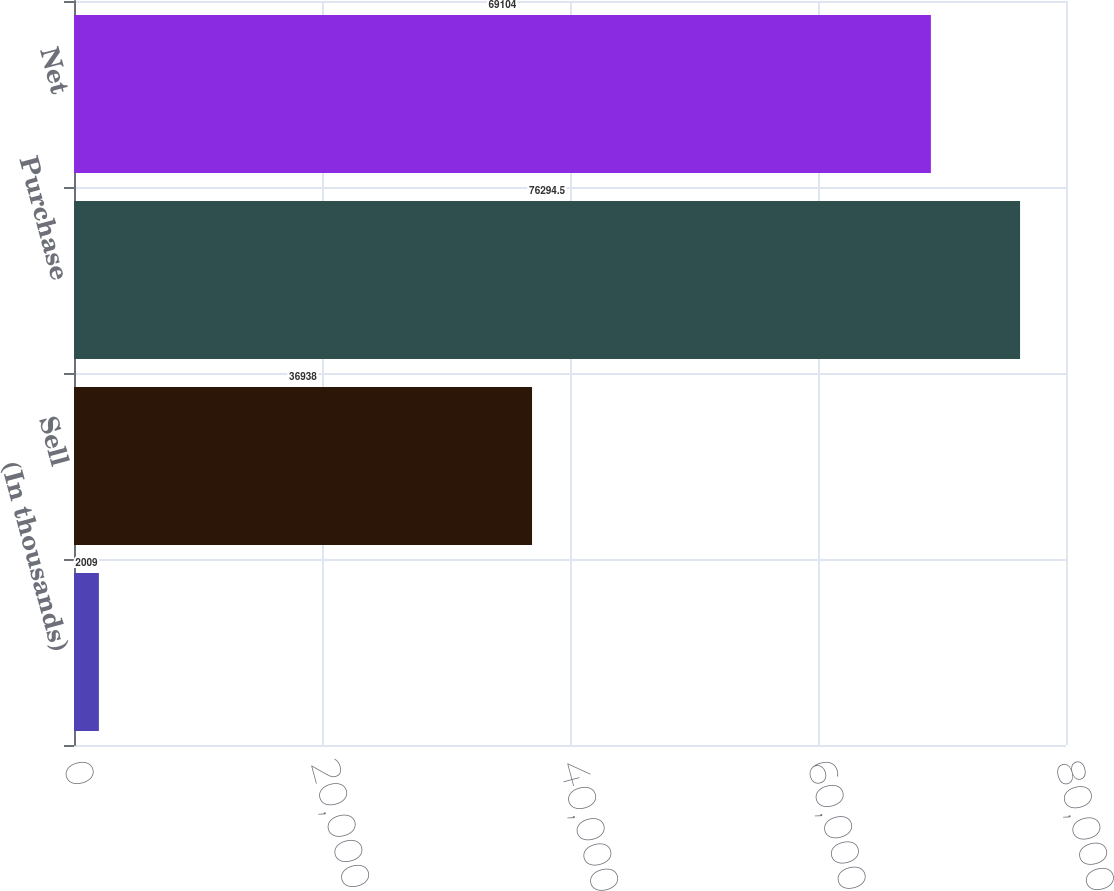Convert chart. <chart><loc_0><loc_0><loc_500><loc_500><bar_chart><fcel>(In thousands)<fcel>Sell<fcel>Purchase<fcel>Net<nl><fcel>2009<fcel>36938<fcel>76294.5<fcel>69104<nl></chart> 